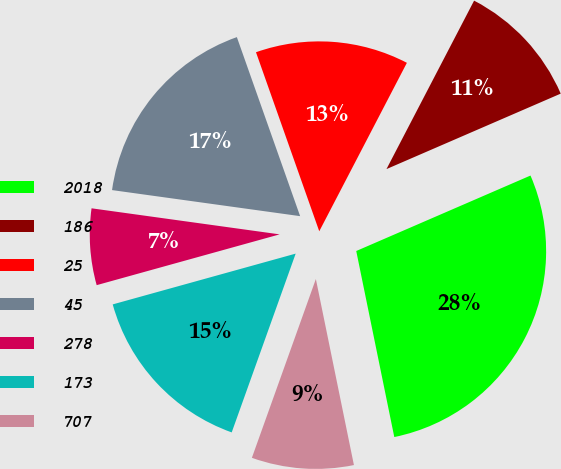<chart> <loc_0><loc_0><loc_500><loc_500><pie_chart><fcel>2018<fcel>186<fcel>25<fcel>45<fcel>278<fcel>173<fcel>707<nl><fcel>28.29%<fcel>10.86%<fcel>13.04%<fcel>17.4%<fcel>6.5%<fcel>15.22%<fcel>8.68%<nl></chart> 